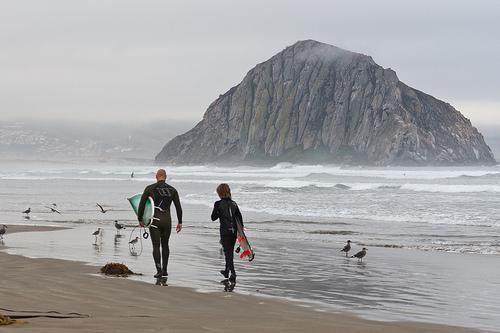How many birds on the beach are the right side of the surfers?
Give a very brief answer. 2. 